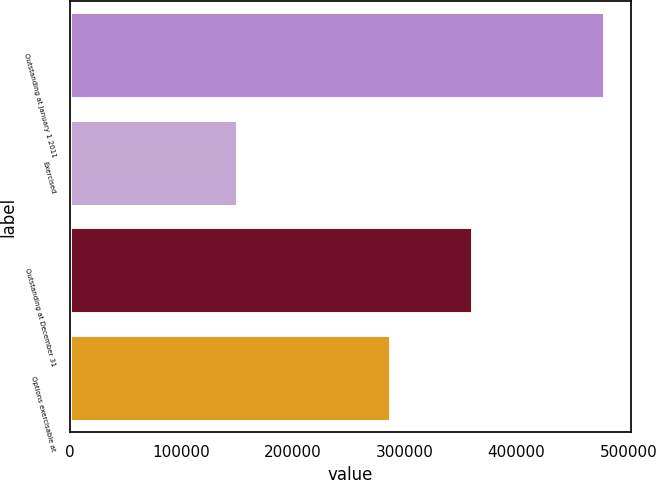<chart> <loc_0><loc_0><loc_500><loc_500><bar_chart><fcel>Outstanding at January 1 2011<fcel>Exercised<fcel>Outstanding at December 31<fcel>Options exercisable at<nl><fcel>478350<fcel>149613<fcel>360611<fcel>286806<nl></chart> 